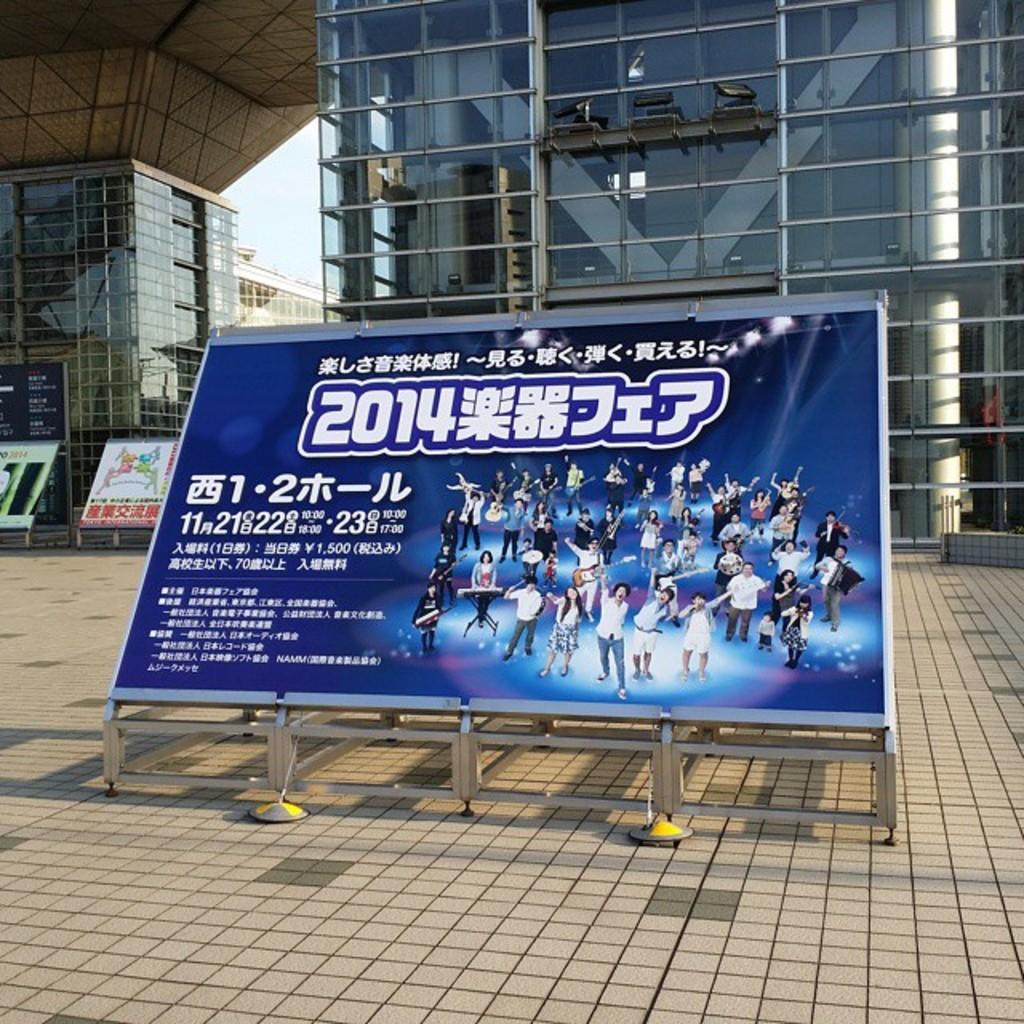<image>
Give a short and clear explanation of the subsequent image. An Asian advertisement for an ice skating show that took place in 2014. 